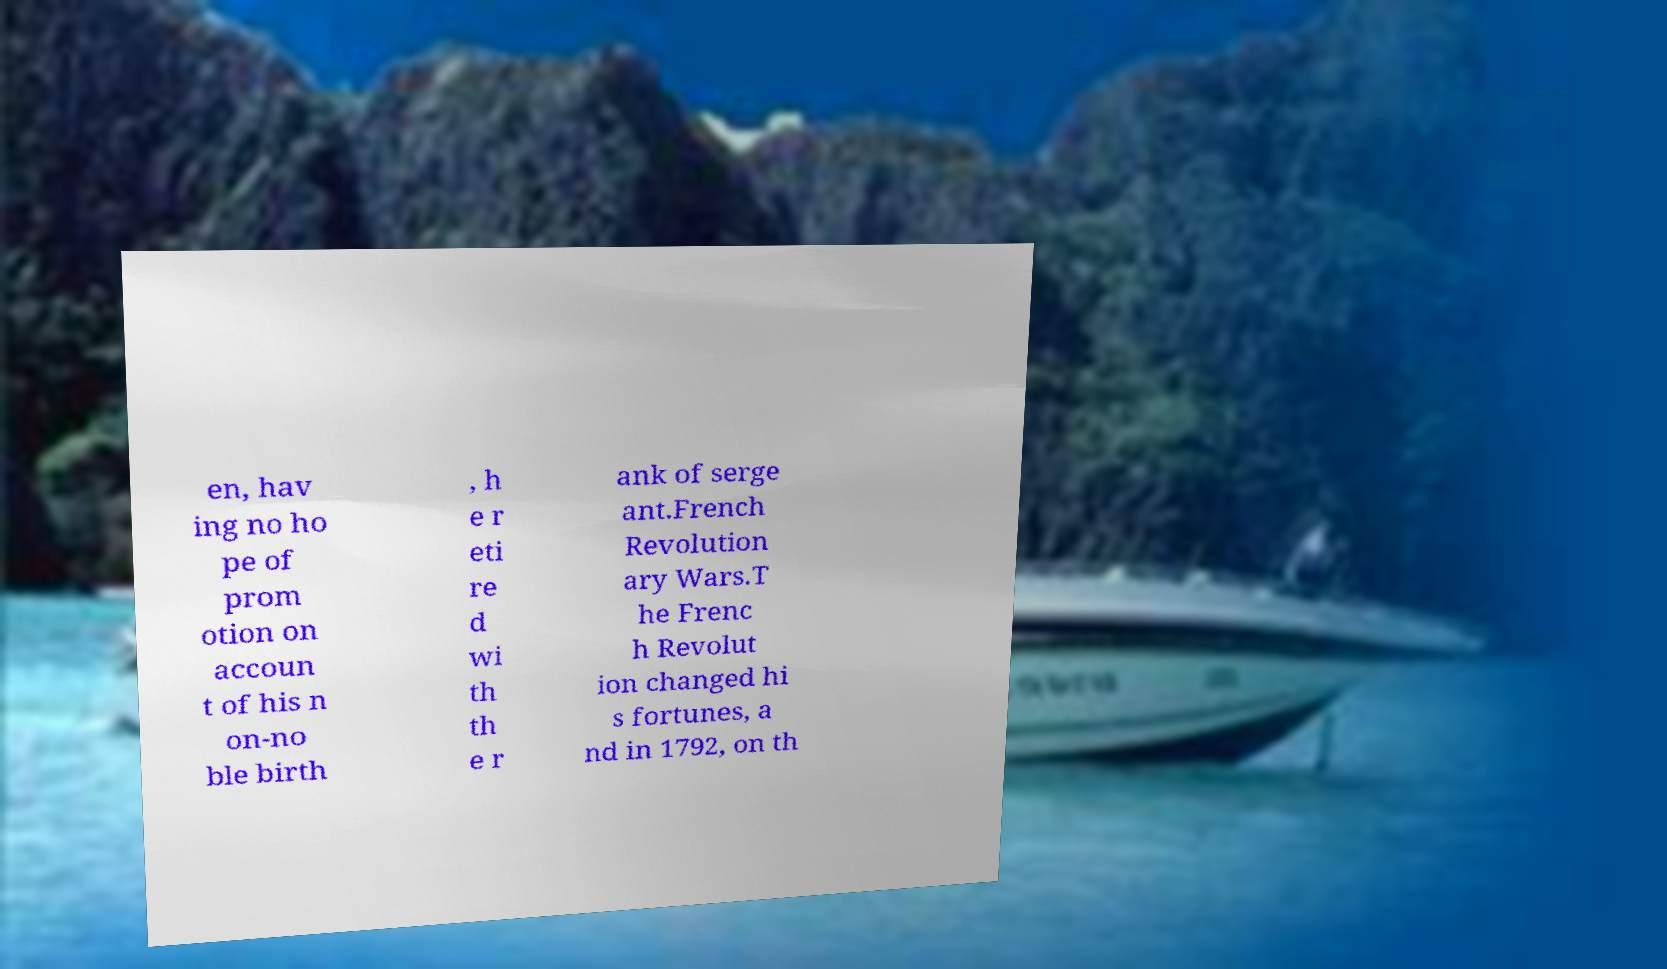There's text embedded in this image that I need extracted. Can you transcribe it verbatim? en, hav ing no ho pe of prom otion on accoun t of his n on-no ble birth , h e r eti re d wi th th e r ank of serge ant.French Revolution ary Wars.T he Frenc h Revolut ion changed hi s fortunes, a nd in 1792, on th 